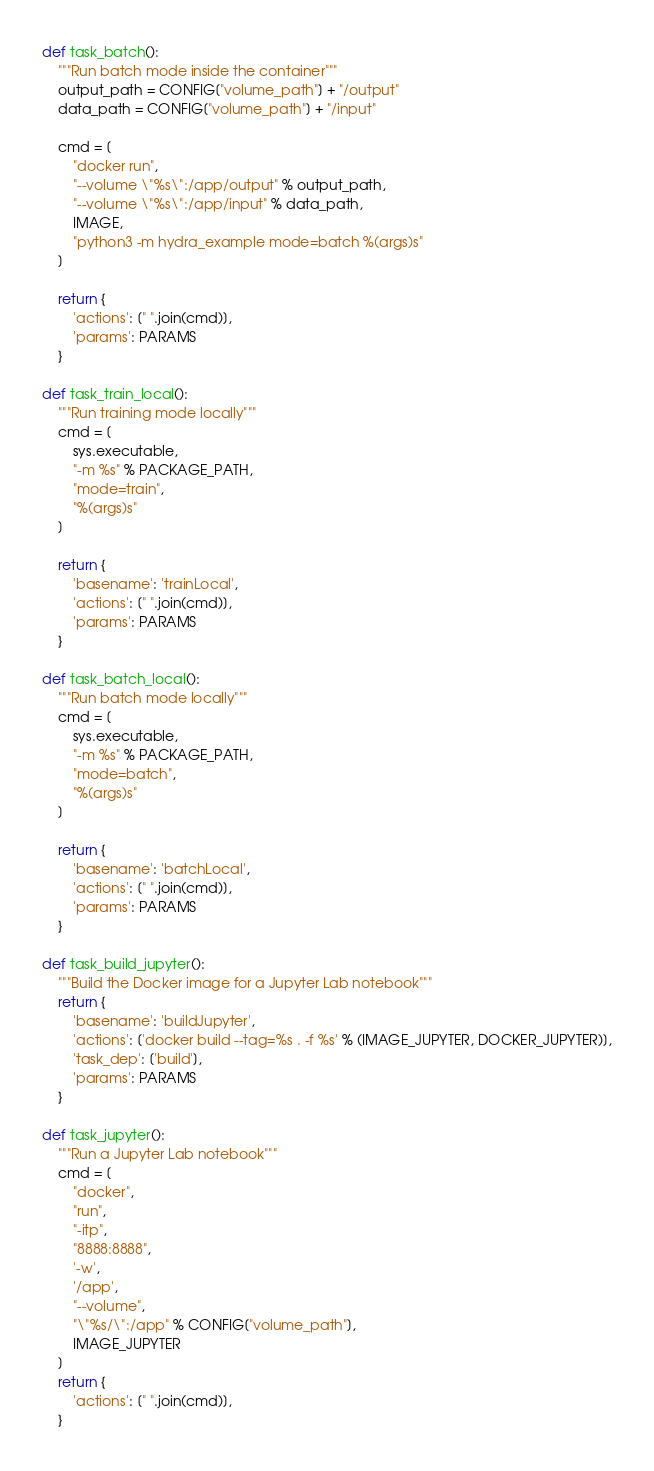<code> <loc_0><loc_0><loc_500><loc_500><_Python_>def task_batch():
    """Run batch mode inside the container"""
    output_path = CONFIG["volume_path"] + "/output"
    data_path = CONFIG["volume_path"] + "/input"

    cmd = [
        "docker run",
        "--volume \"%s\":/app/output" % output_path,
        "--volume \"%s\":/app/input" % data_path,
        IMAGE,
        "python3 -m hydra_example mode=batch %(args)s"
    ]

    return {
        'actions': [" ".join(cmd)],
        'params': PARAMS
    }

def task_train_local():
    """Run training mode locally"""
    cmd = [
        sys.executable,
        "-m %s" % PACKAGE_PATH,
        "mode=train",
        "%(args)s"
    ]

    return {
        'basename': 'trainLocal',
        'actions': [" ".join(cmd)],
        'params': PARAMS
    }

def task_batch_local():
    """Run batch mode locally"""
    cmd = [
        sys.executable,
        "-m %s" % PACKAGE_PATH,
        "mode=batch",
        "%(args)s"
    ]

    return {
        'basename': 'batchLocal',
        'actions': [" ".join(cmd)],
        'params': PARAMS
    }

def task_build_jupyter():
    """Build the Docker image for a Jupyter Lab notebook"""
    return {
        'basename': 'buildJupyter',
        'actions': ['docker build --tag=%s . -f %s' % (IMAGE_JUPYTER, DOCKER_JUPYTER)],
        'task_dep': ['build'],
        'params': PARAMS
    }

def task_jupyter():
    """Run a Jupyter Lab notebook"""
    cmd = [
        "docker",
        "run",
        "-itp",
        "8888:8888",
        '-w',
        '/app',
        "--volume",
        "\"%s/\":/app" % CONFIG["volume_path"],
        IMAGE_JUPYTER
    ]
    return {
        'actions': [" ".join(cmd)],
    }
</code> 